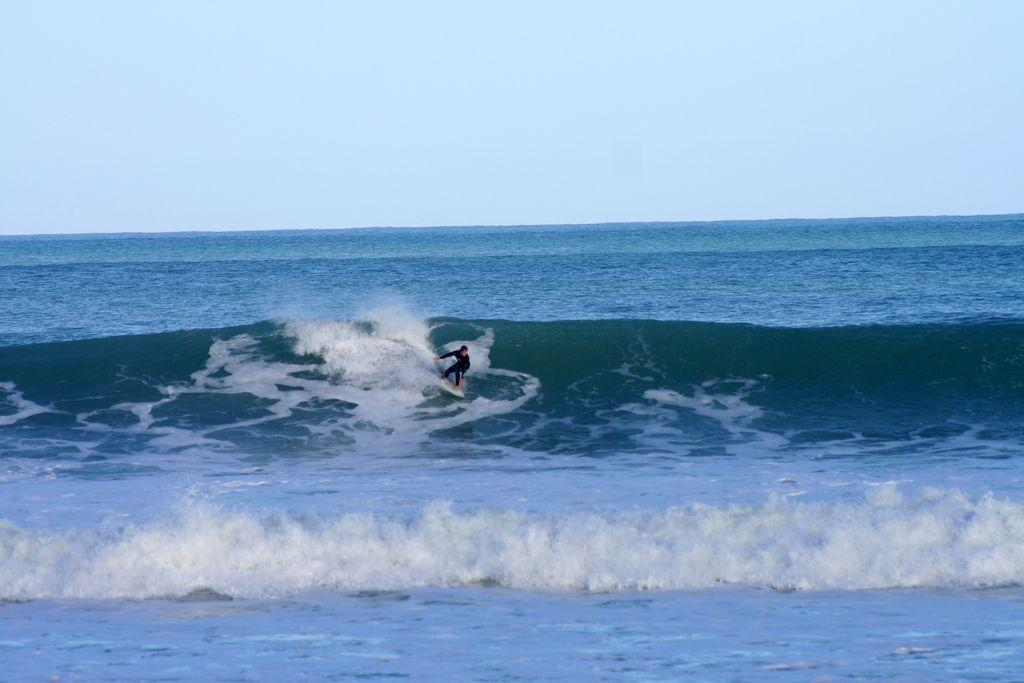Who is the main subject in the image? There is a boy in the image. What is the boy wearing? The boy is wearing a black costume. What activity is the boy engaged in? The boy is surfing on a boat. Where is the boat located? The boat is in the sea water. What color is the sea water in the image? The sea water is blue in the image. What is visible at the top of the image? The sky is visible at the top of the image. What type of vest can be seen on the boy in the image? There is no vest visible on the boy in the image; he is wearing a black costume. What kind of marble is present in the image? There is no marble present in the image; it features a boy surfing on a boat in the sea. 